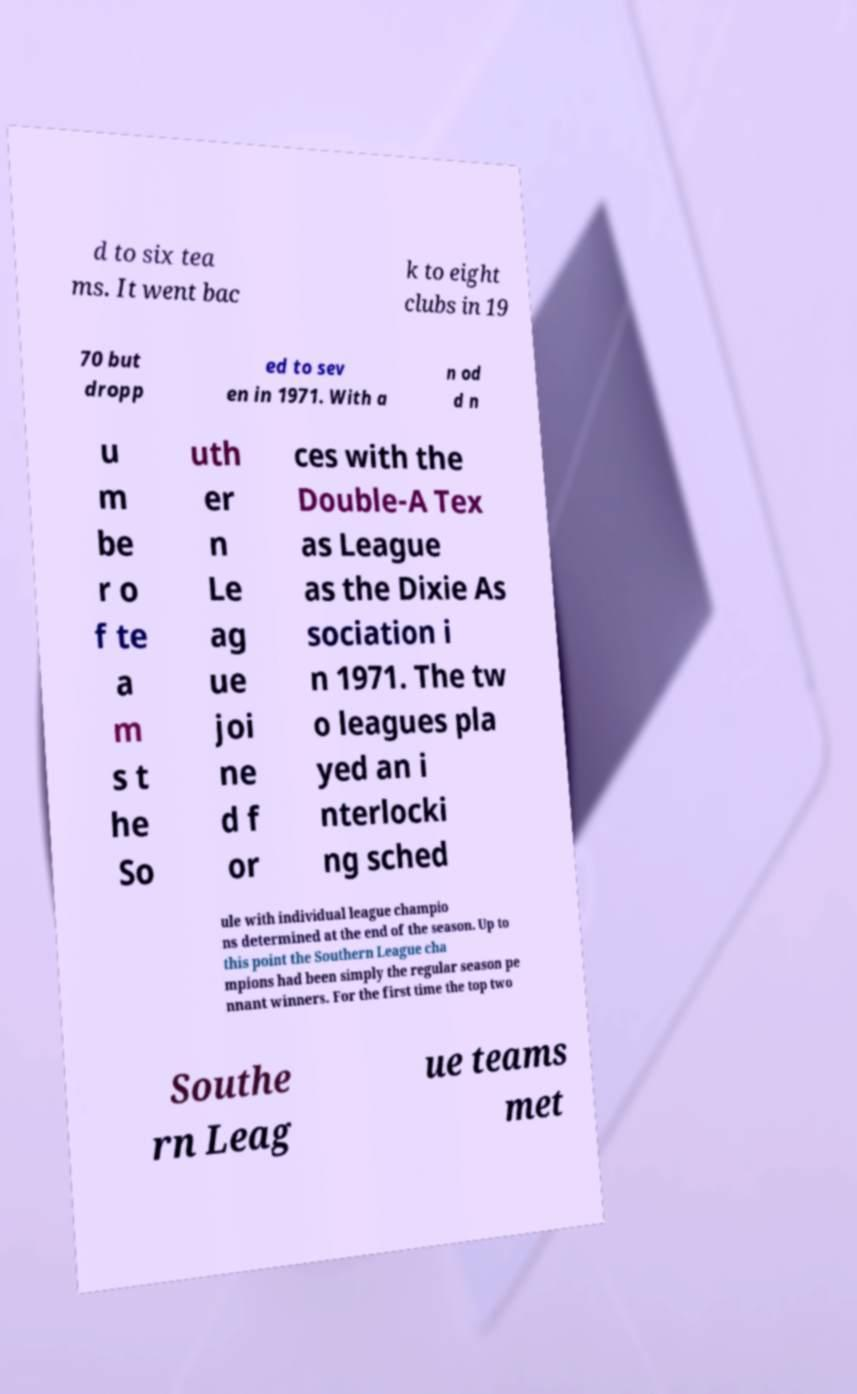For documentation purposes, I need the text within this image transcribed. Could you provide that? d to six tea ms. It went bac k to eight clubs in 19 70 but dropp ed to sev en in 1971. With a n od d n u m be r o f te a m s t he So uth er n Le ag ue joi ne d f or ces with the Double-A Tex as League as the Dixie As sociation i n 1971. The tw o leagues pla yed an i nterlocki ng sched ule with individual league champio ns determined at the end of the season. Up to this point the Southern League cha mpions had been simply the regular season pe nnant winners. For the first time the top two Southe rn Leag ue teams met 